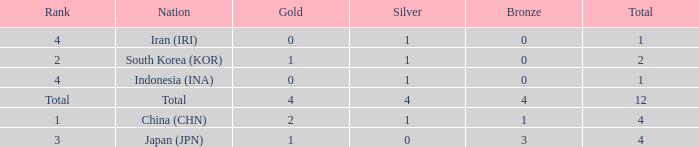How many silver medals for the nation with fewer than 1 golds and total less than 1? 0.0. 